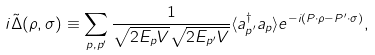Convert formula to latex. <formula><loc_0><loc_0><loc_500><loc_500>i \tilde { \Delta } ( \rho , \sigma ) \equiv \sum _ { p , p ^ { \prime } } \frac { 1 } { \sqrt { 2 E _ { p } V } \sqrt { 2 E _ { p ^ { \prime } } V } } \langle a _ { p ^ { \prime } } ^ { \dagger } a _ { p } \rangle e ^ { - i ( P \cdot \rho - P ^ { \prime } \cdot \sigma ) } ,</formula> 